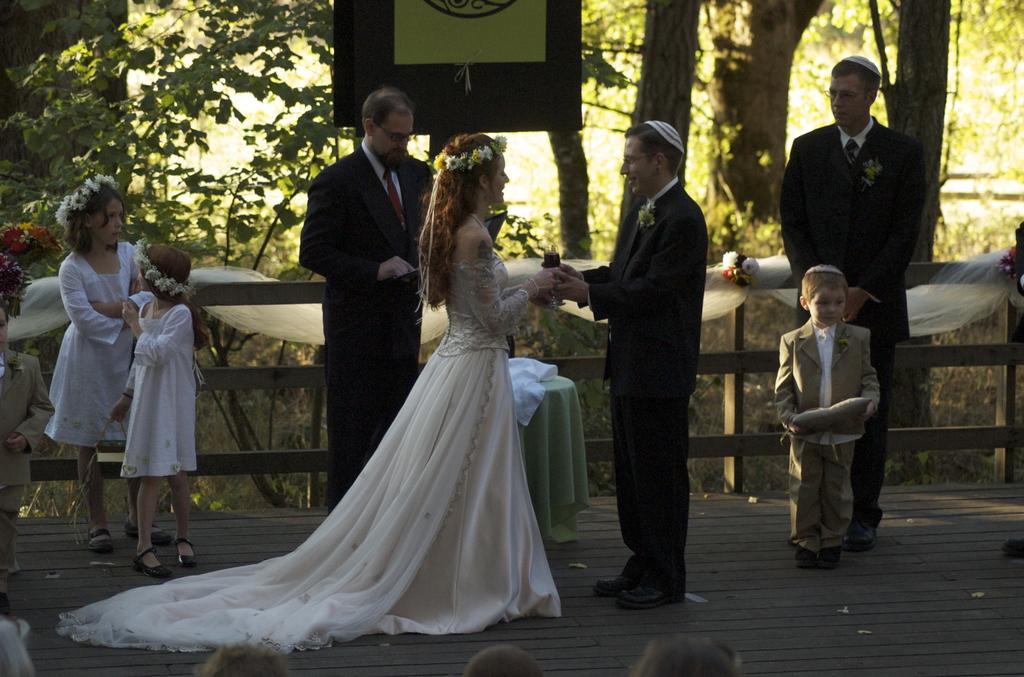Please provide a concise description of this image. In this picture I can see few people are standing and I can see a man and a woman holding a glass with their hands and I can see a table and few trees in the back and I can see audience at the bottom of the picture. 